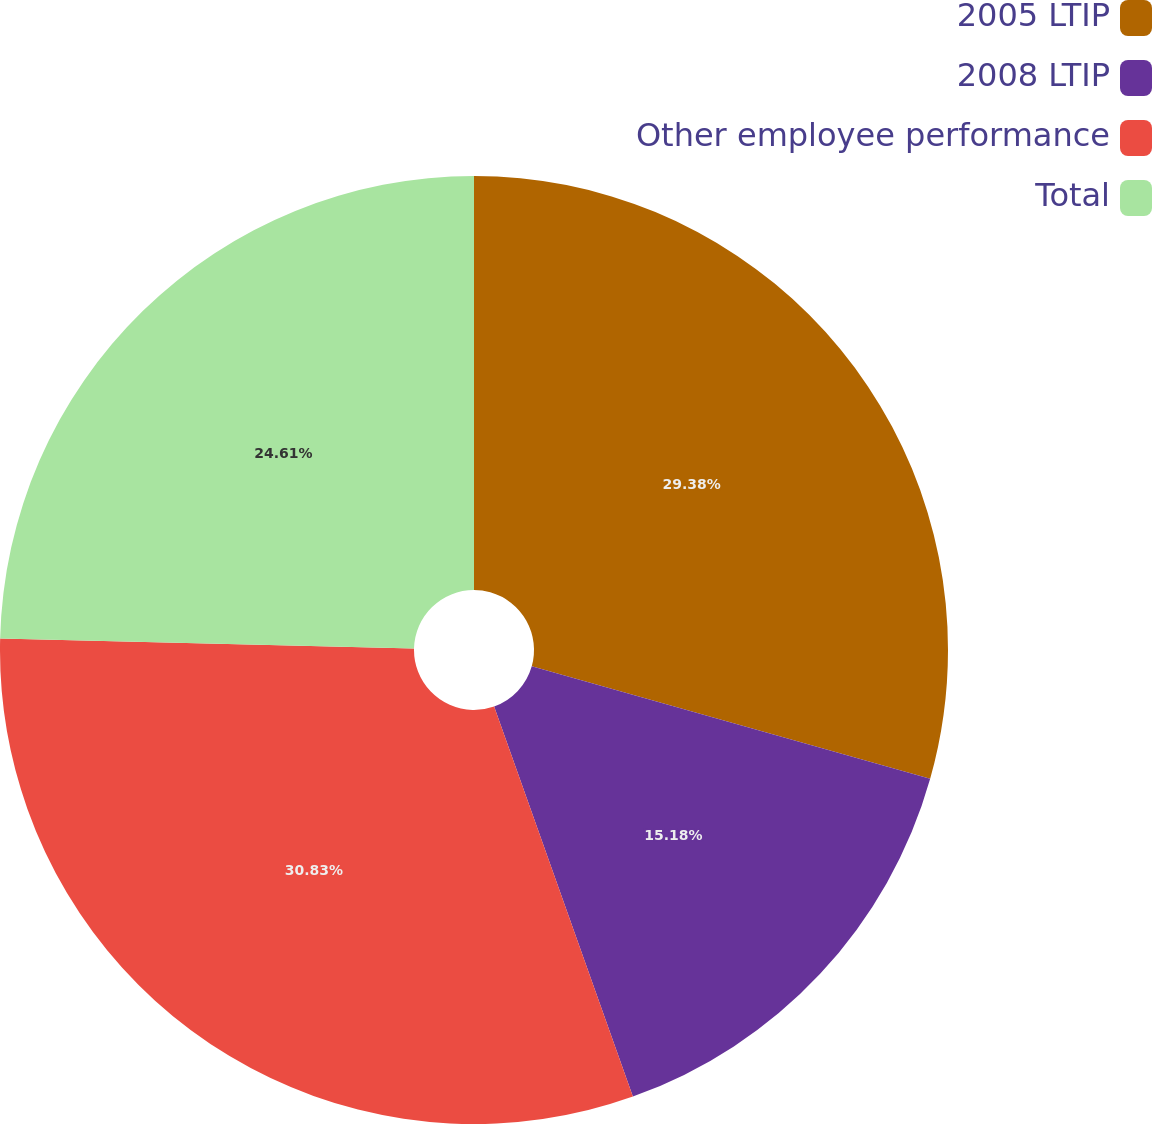Convert chart to OTSL. <chart><loc_0><loc_0><loc_500><loc_500><pie_chart><fcel>2005 LTIP<fcel>2008 LTIP<fcel>Other employee performance<fcel>Total<nl><fcel>29.38%<fcel>15.18%<fcel>30.83%<fcel>24.61%<nl></chart> 